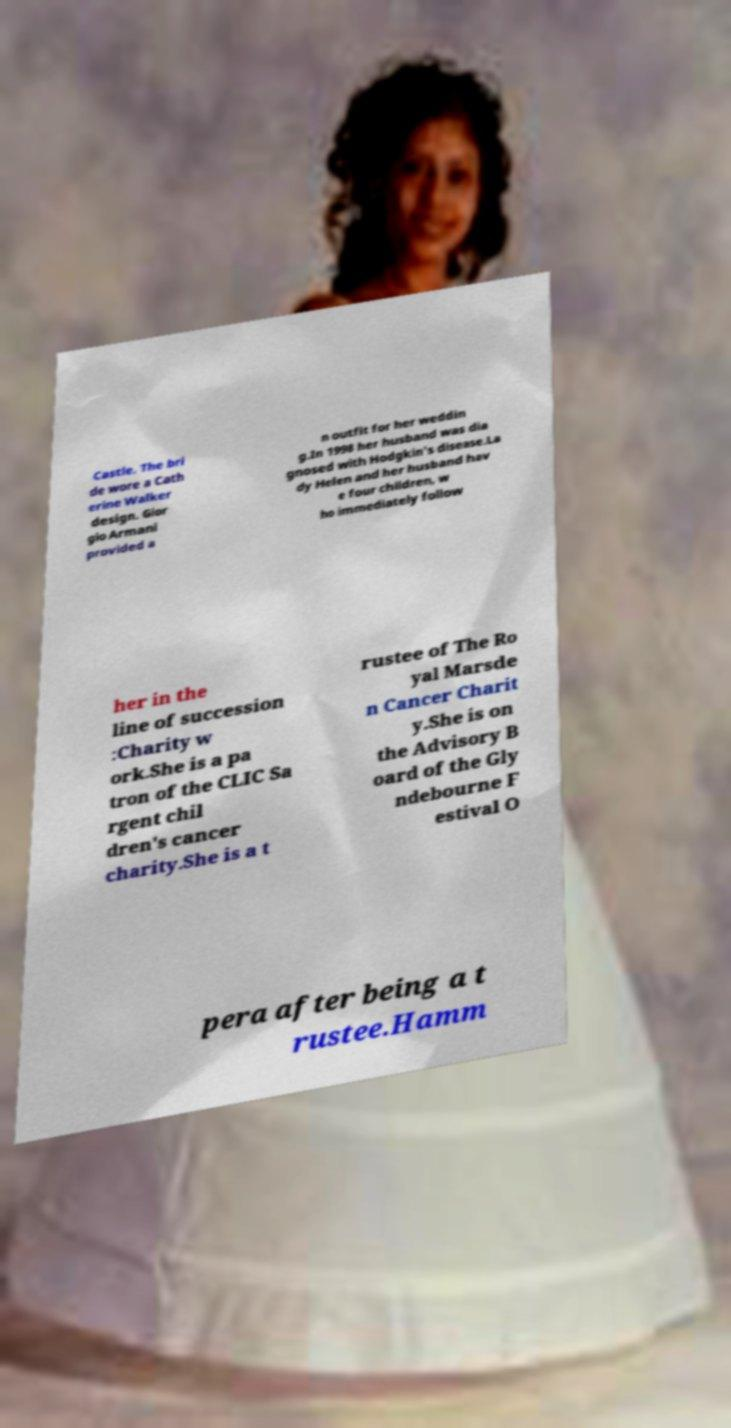Please read and relay the text visible in this image. What does it say? Castle. The bri de wore a Cath erine Walker design. Gior gio Armani provided a n outfit for her weddin g.In 1998 her husband was dia gnosed with Hodgkin's disease.La dy Helen and her husband hav e four children, w ho immediately follow her in the line of succession :Charity w ork.She is a pa tron of the CLIC Sa rgent chil dren's cancer charity.She is a t rustee of The Ro yal Marsde n Cancer Charit y.She is on the Advisory B oard of the Gly ndebourne F estival O pera after being a t rustee.Hamm 